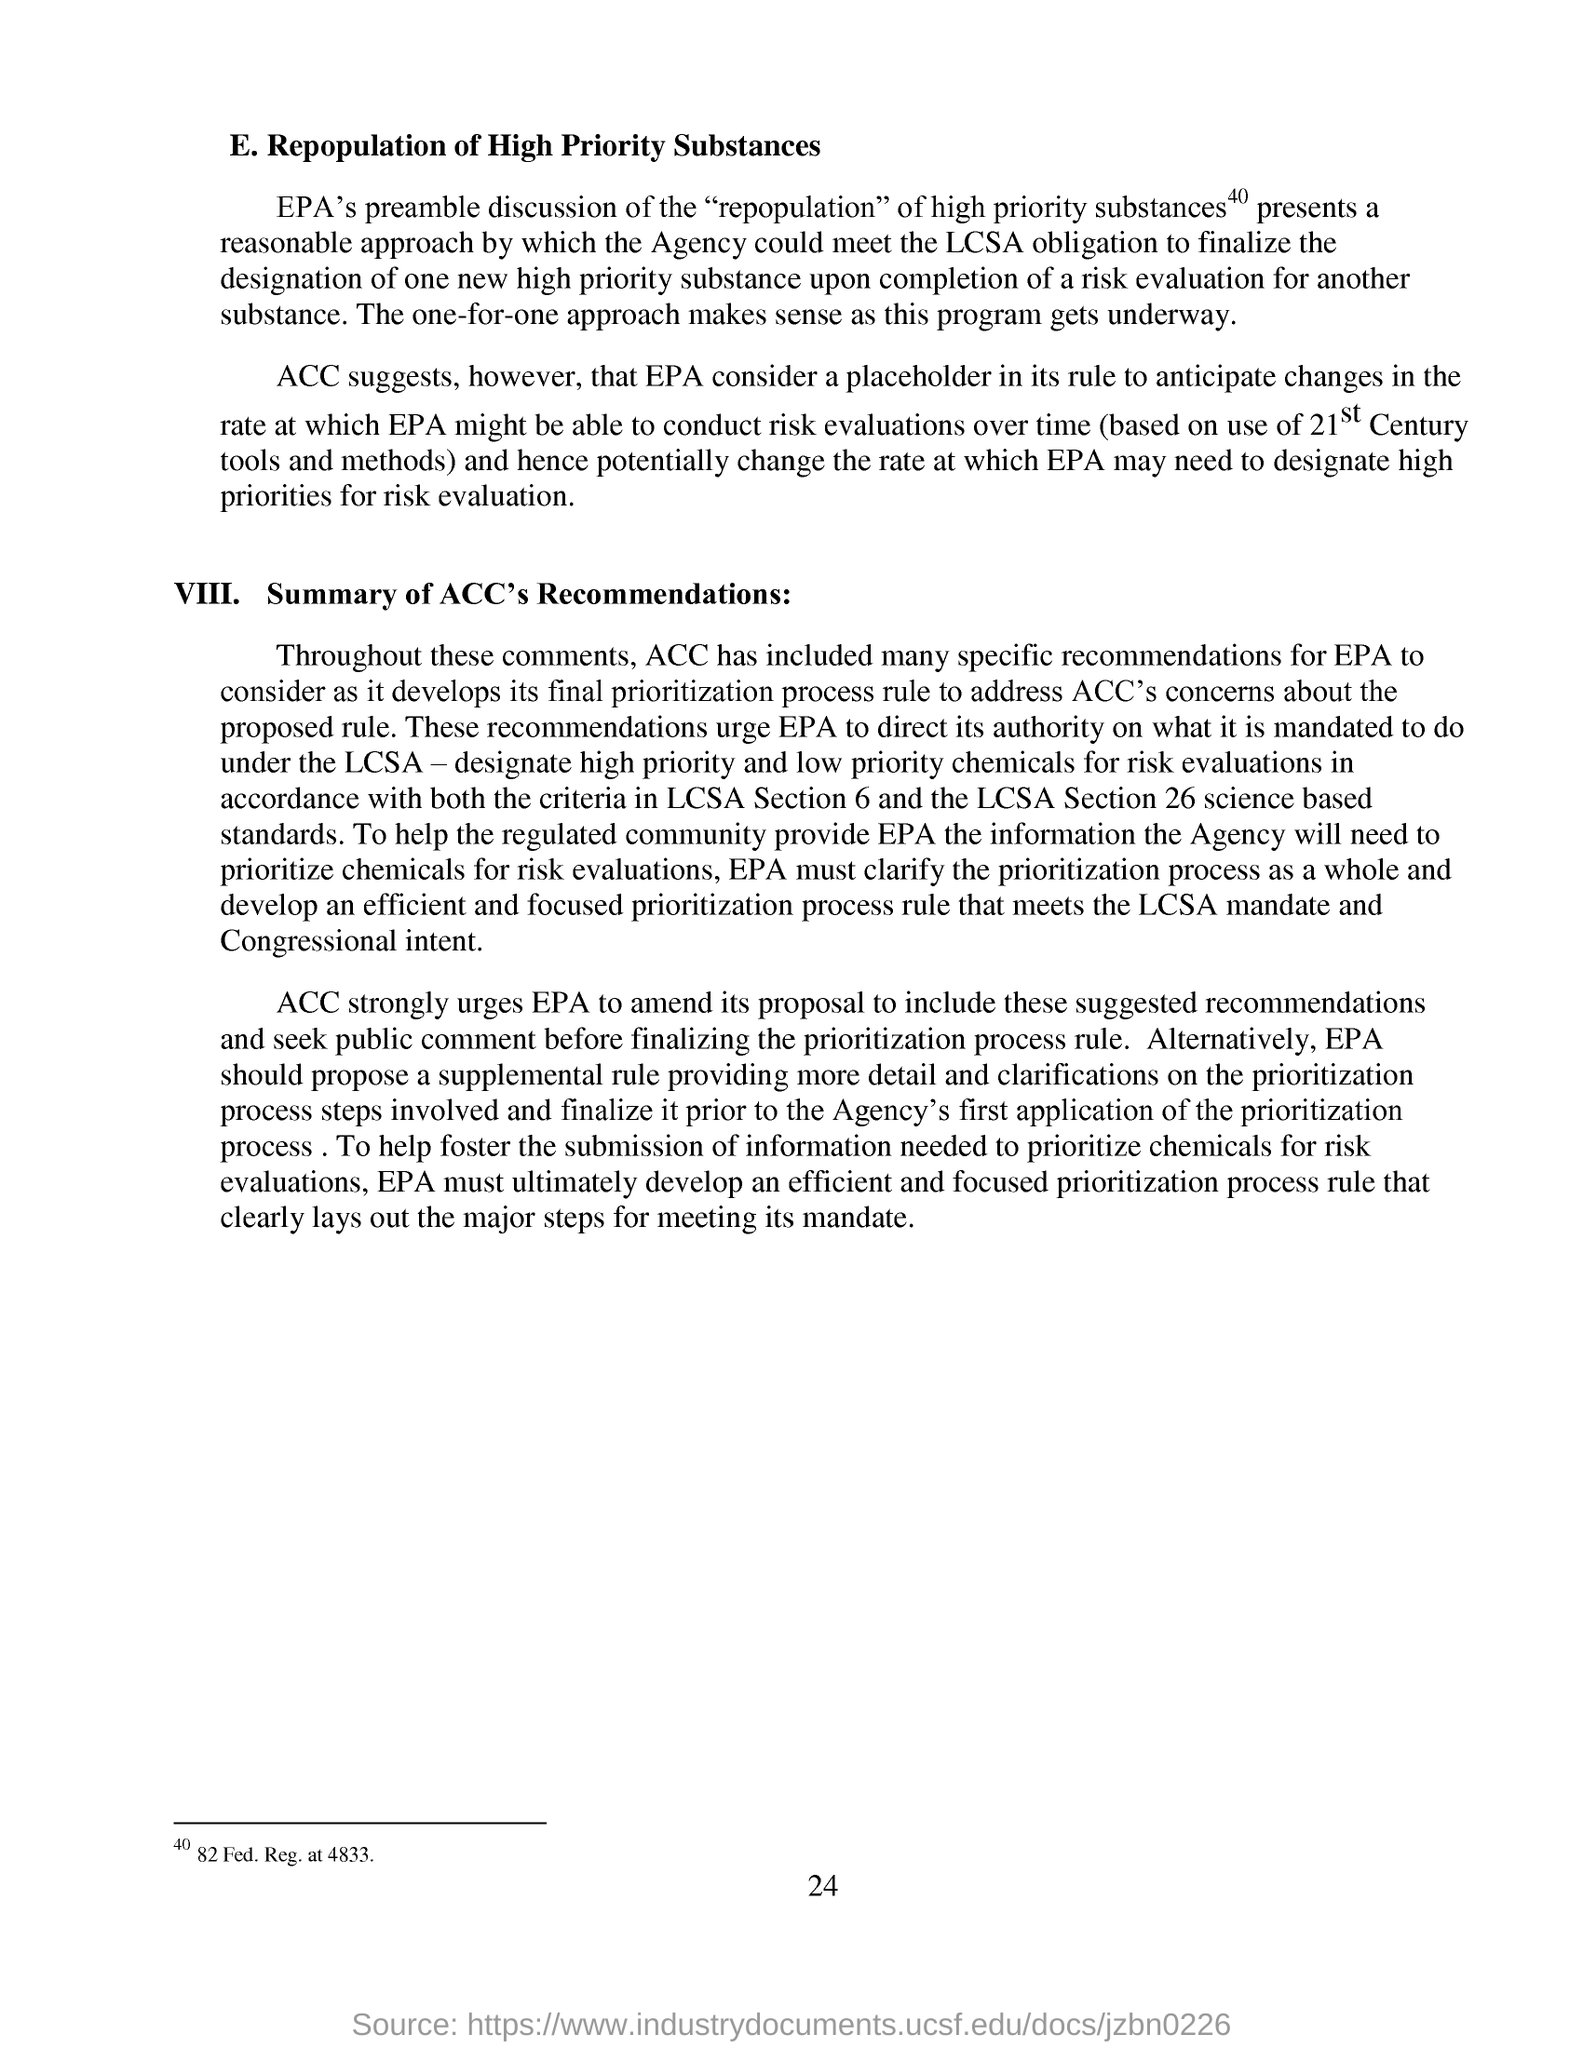Draw attention to some important aspects in this diagram. The first paragraph is about the repopulation of high priority substances. The Environmental Protection Agency may prioritize risk evaluations that utilize the tools and methods of the 21st century, rather than those of previous centuries, in order to effectively safeguard public health and the environment. The second paragraph's heading is VIII. Summary of ACC's Recommendations. The page number mentioned in this document is 24. 